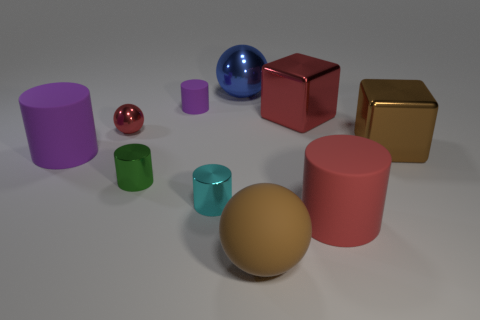Subtract all red cylinders. How many cylinders are left? 4 Subtract all cyan cylinders. How many cylinders are left? 4 Subtract all blue cylinders. Subtract all brown balls. How many cylinders are left? 5 Subtract all spheres. How many objects are left? 7 Subtract all tiny cyan spheres. Subtract all rubber things. How many objects are left? 6 Add 4 matte objects. How many matte objects are left? 8 Add 2 small purple blocks. How many small purple blocks exist? 2 Subtract 1 cyan cylinders. How many objects are left? 9 